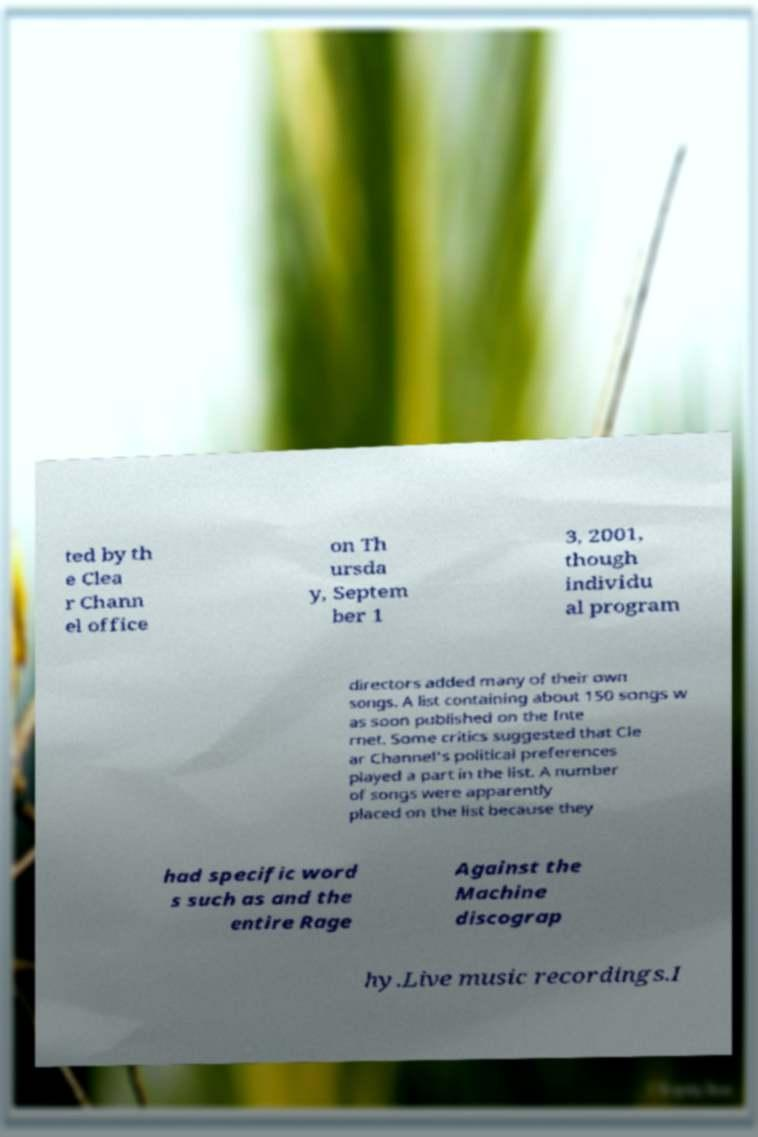Could you extract and type out the text from this image? ted by th e Clea r Chann el office on Th ursda y, Septem ber 1 3, 2001, though individu al program directors added many of their own songs. A list containing about 150 songs w as soon published on the Inte rnet. Some critics suggested that Cle ar Channel's political preferences played a part in the list. A number of songs were apparently placed on the list because they had specific word s such as and the entire Rage Against the Machine discograp hy.Live music recordings.I 